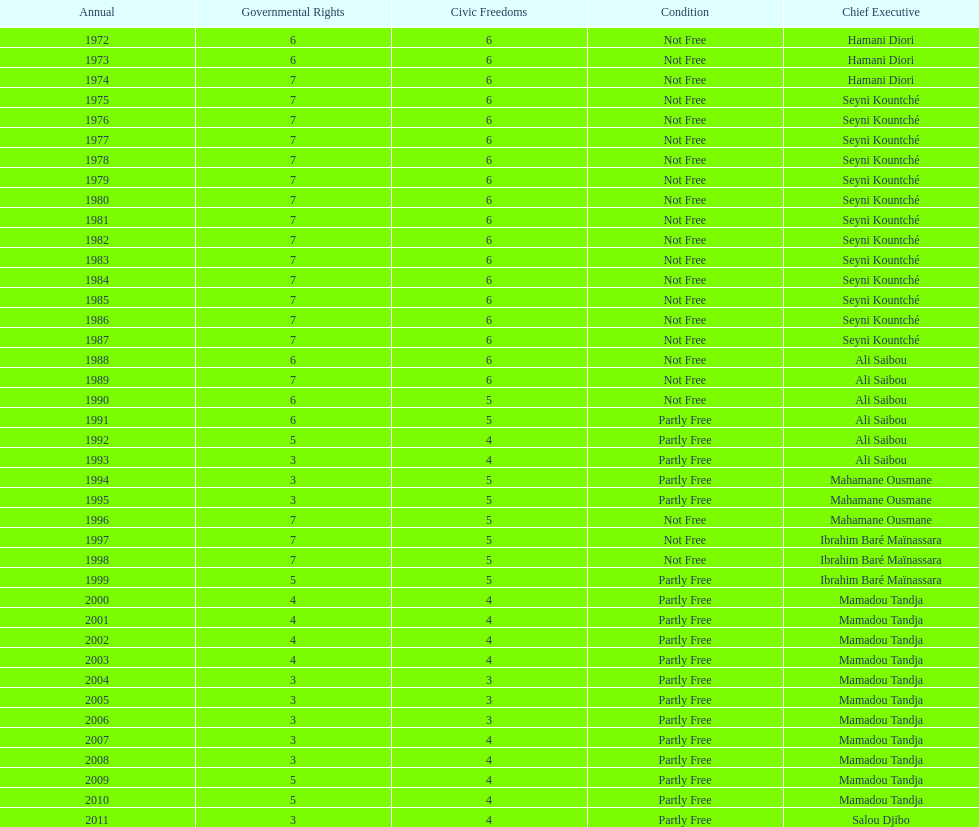How many years was ali saibou president? 6. 